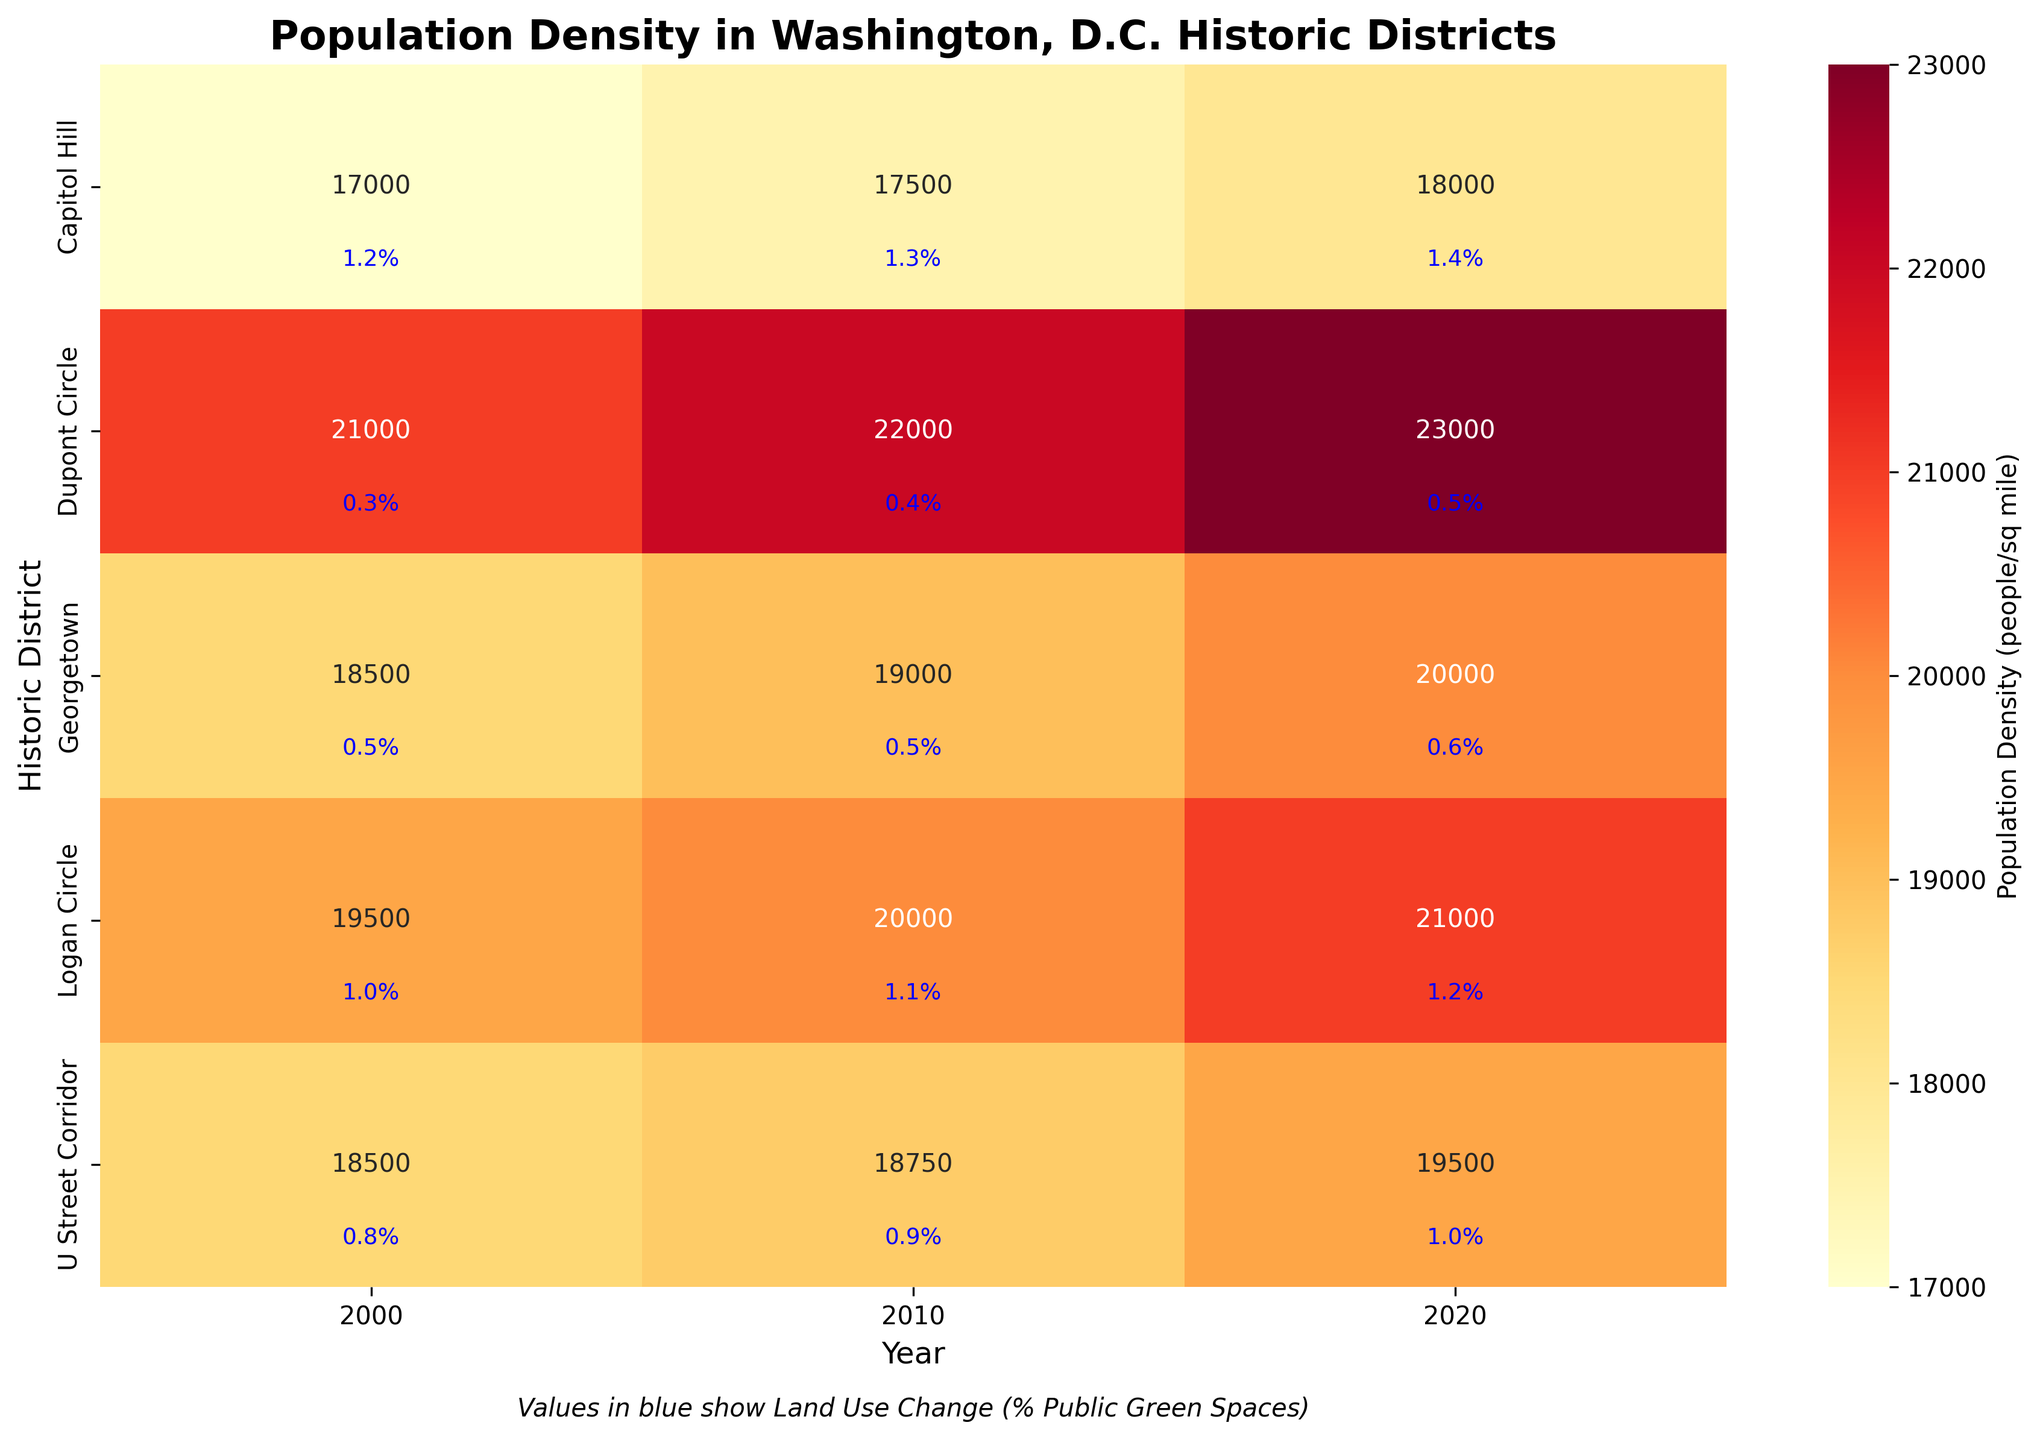How has the population density in Georgetown changed from 2000 to 2020? Look at the population density values for Georgetown in 2000, 2010, and 2020. Subtract the 2000 value from the 2020 value to get the change in population density.
Answer: Increased by 1,500 people/sq mile Which historic district had the highest population density in 2010? Compare the population density values of all the historic districts in the year 2010. Identify the highest value.
Answer: Dupont Circle Did the percentage of public green spaces in Logan Circle increase, decrease, or remain the same from 2000 to 2020? Compare the land use change percentage for Logan Circle in 2000, 2010, and 2020. Observe if the percentage value increases, decreases, or remains the same over these years.
Answer: Increase What is the average population density in U Street Corridor across all years? Collect the population density values for U Street Corridor for the years 2000, 2010, and 2020, then calculate their average by summing these values and dividing by the number of years.
Answer: 18,583 people/sq mile Compare the change in public green spaces between Capitol Hill and Dupont Circle from 2000 to 2020. Which district had a larger increase? Calculate the difference in the percentage of public green spaces for each district between 2000 and 2020. Compare the two differences to determine which one is larger.
Answer: Capitol Hill What years show a population density of 20,000 people/sq mile or greater in Georgetown? Check the population density values for Georgetown across different years and note the years where the density is 20,000 people/sq mile or greater.
Answer: 2020 Among the listed historic districts, which one experienced the least change in public green spaces from 2000 to 2020? Analyze the land use change percentages for each district over the years. Identify which district has the smallest difference between 2000 and 2020 values.
Answer: Georgetown Which historic district had the lowest population density in 2020? Compare the population density values of all historic districts in the year 2020. Identify the lowest value.
Answer: Capitol Hill 